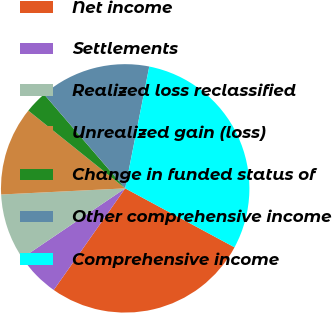Convert chart. <chart><loc_0><loc_0><loc_500><loc_500><pie_chart><fcel>Net income<fcel>Settlements<fcel>Realized loss reclassified<fcel>Unrealized gain (loss)<fcel>Change in funded status of<fcel>Other comprehensive income<fcel>Comprehensive income<nl><fcel>26.88%<fcel>5.79%<fcel>8.67%<fcel>11.55%<fcel>2.91%<fcel>14.43%<fcel>29.76%<nl></chart> 